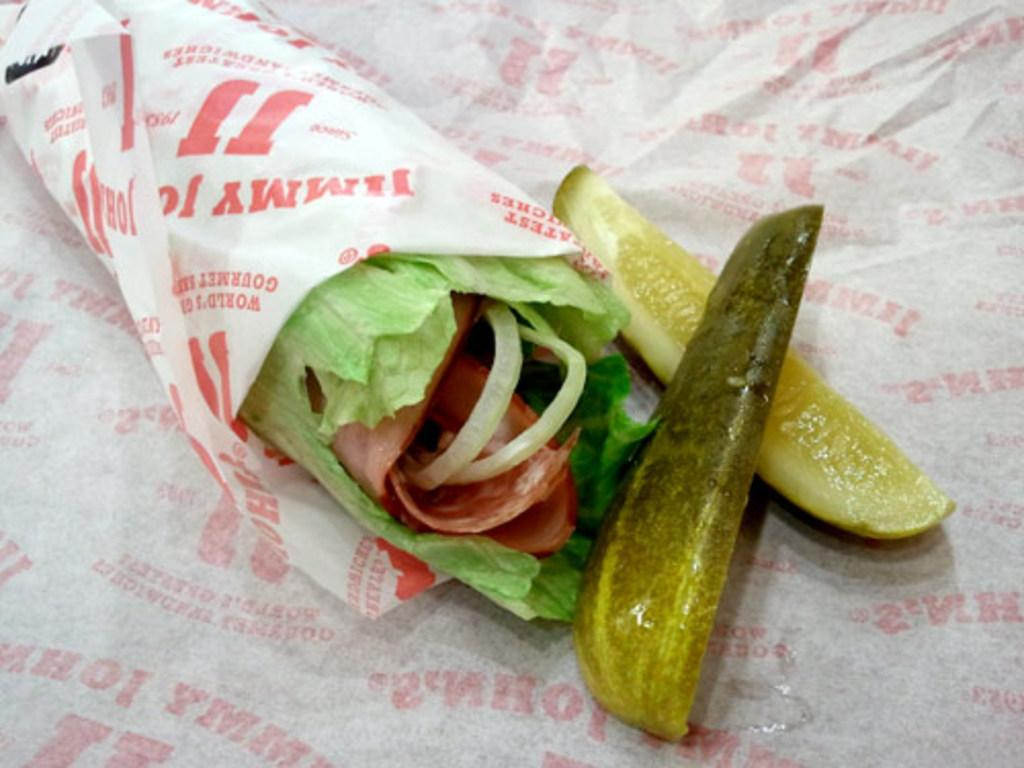What is wrapped in the wrapper that is visible in the image? There is food wrapped in a wrapper in the image. What can be seen on the wrapper? There is text present on the wrapper. What type of vegetable is present in the image? There are cucumber pieces in the image. What is visible in the background of the image? There is a paper in the background of the image. Can you tell me how many horses are depicted in the image? There are no horses present in the image. What type of wine is being served with the food in the image? There is no wine present in the image; it only shows food wrapped in a wrapper and cucumber pieces. 